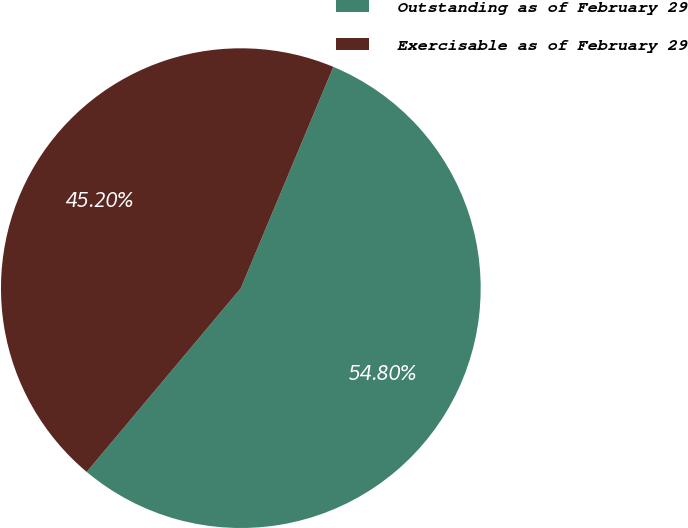Convert chart. <chart><loc_0><loc_0><loc_500><loc_500><pie_chart><fcel>Outstanding as of February 29<fcel>Exercisable as of February 29<nl><fcel>54.8%<fcel>45.2%<nl></chart> 